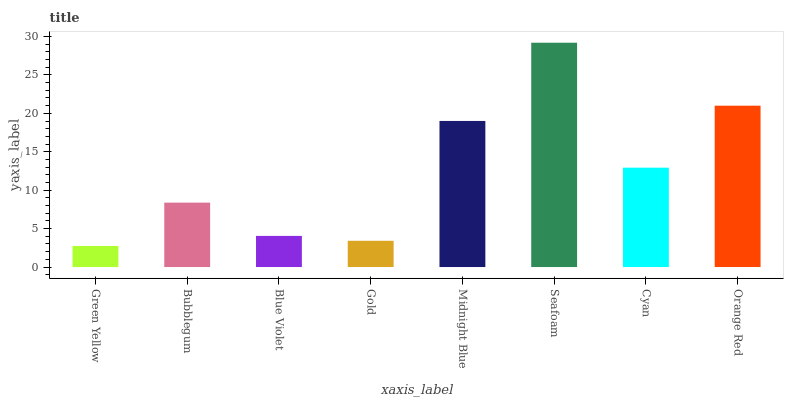Is Bubblegum the minimum?
Answer yes or no. No. Is Bubblegum the maximum?
Answer yes or no. No. Is Bubblegum greater than Green Yellow?
Answer yes or no. Yes. Is Green Yellow less than Bubblegum?
Answer yes or no. Yes. Is Green Yellow greater than Bubblegum?
Answer yes or no. No. Is Bubblegum less than Green Yellow?
Answer yes or no. No. Is Cyan the high median?
Answer yes or no. Yes. Is Bubblegum the low median?
Answer yes or no. Yes. Is Midnight Blue the high median?
Answer yes or no. No. Is Cyan the low median?
Answer yes or no. No. 